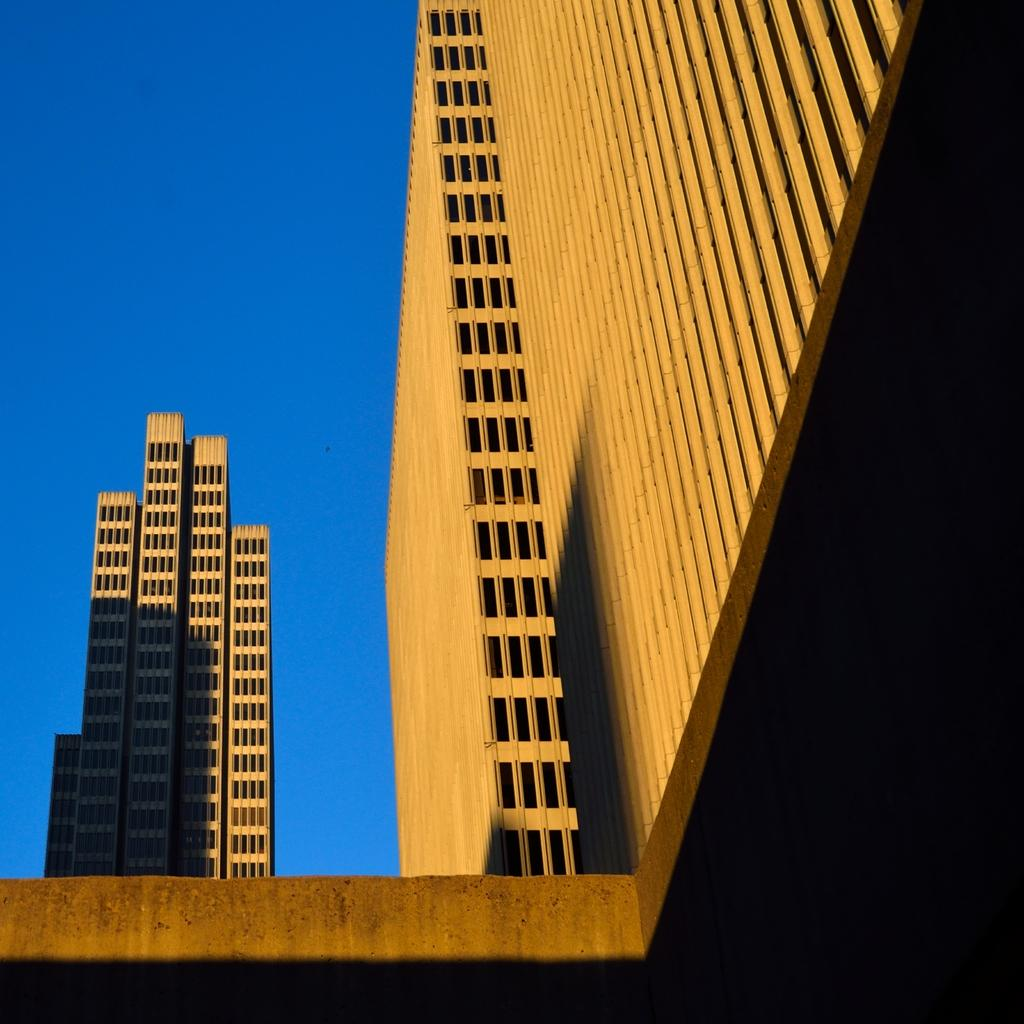What type of structures are visible in the image? There are buildings in the image. What feature can be seen on the buildings? The buildings have windows. What color is the sky in the image? The sky is blue in the image. What type of haircut is visible on the buildings in the image? There is no haircut present on the buildings in the image; they are structures, not people. 